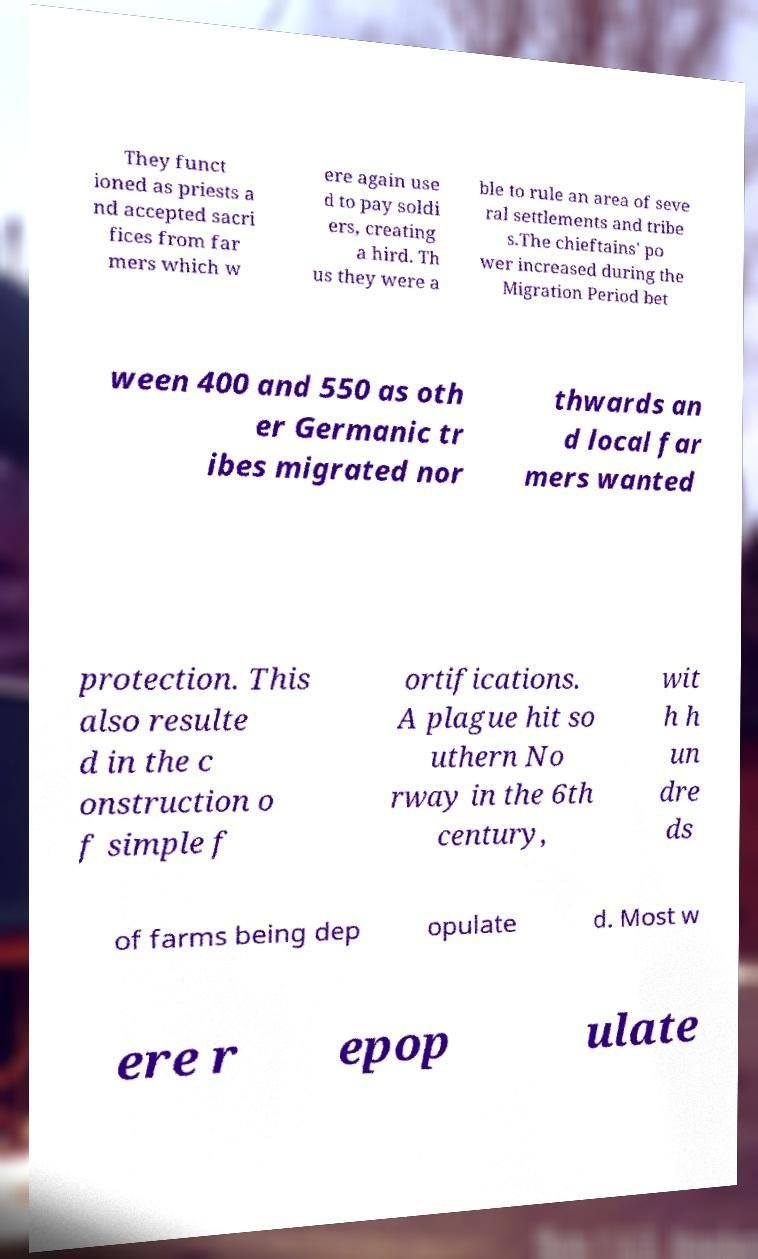There's text embedded in this image that I need extracted. Can you transcribe it verbatim? They funct ioned as priests a nd accepted sacri fices from far mers which w ere again use d to pay soldi ers, creating a hird. Th us they were a ble to rule an area of seve ral settlements and tribe s.The chieftains' po wer increased during the Migration Period bet ween 400 and 550 as oth er Germanic tr ibes migrated nor thwards an d local far mers wanted protection. This also resulte d in the c onstruction o f simple f ortifications. A plague hit so uthern No rway in the 6th century, wit h h un dre ds of farms being dep opulate d. Most w ere r epop ulate 